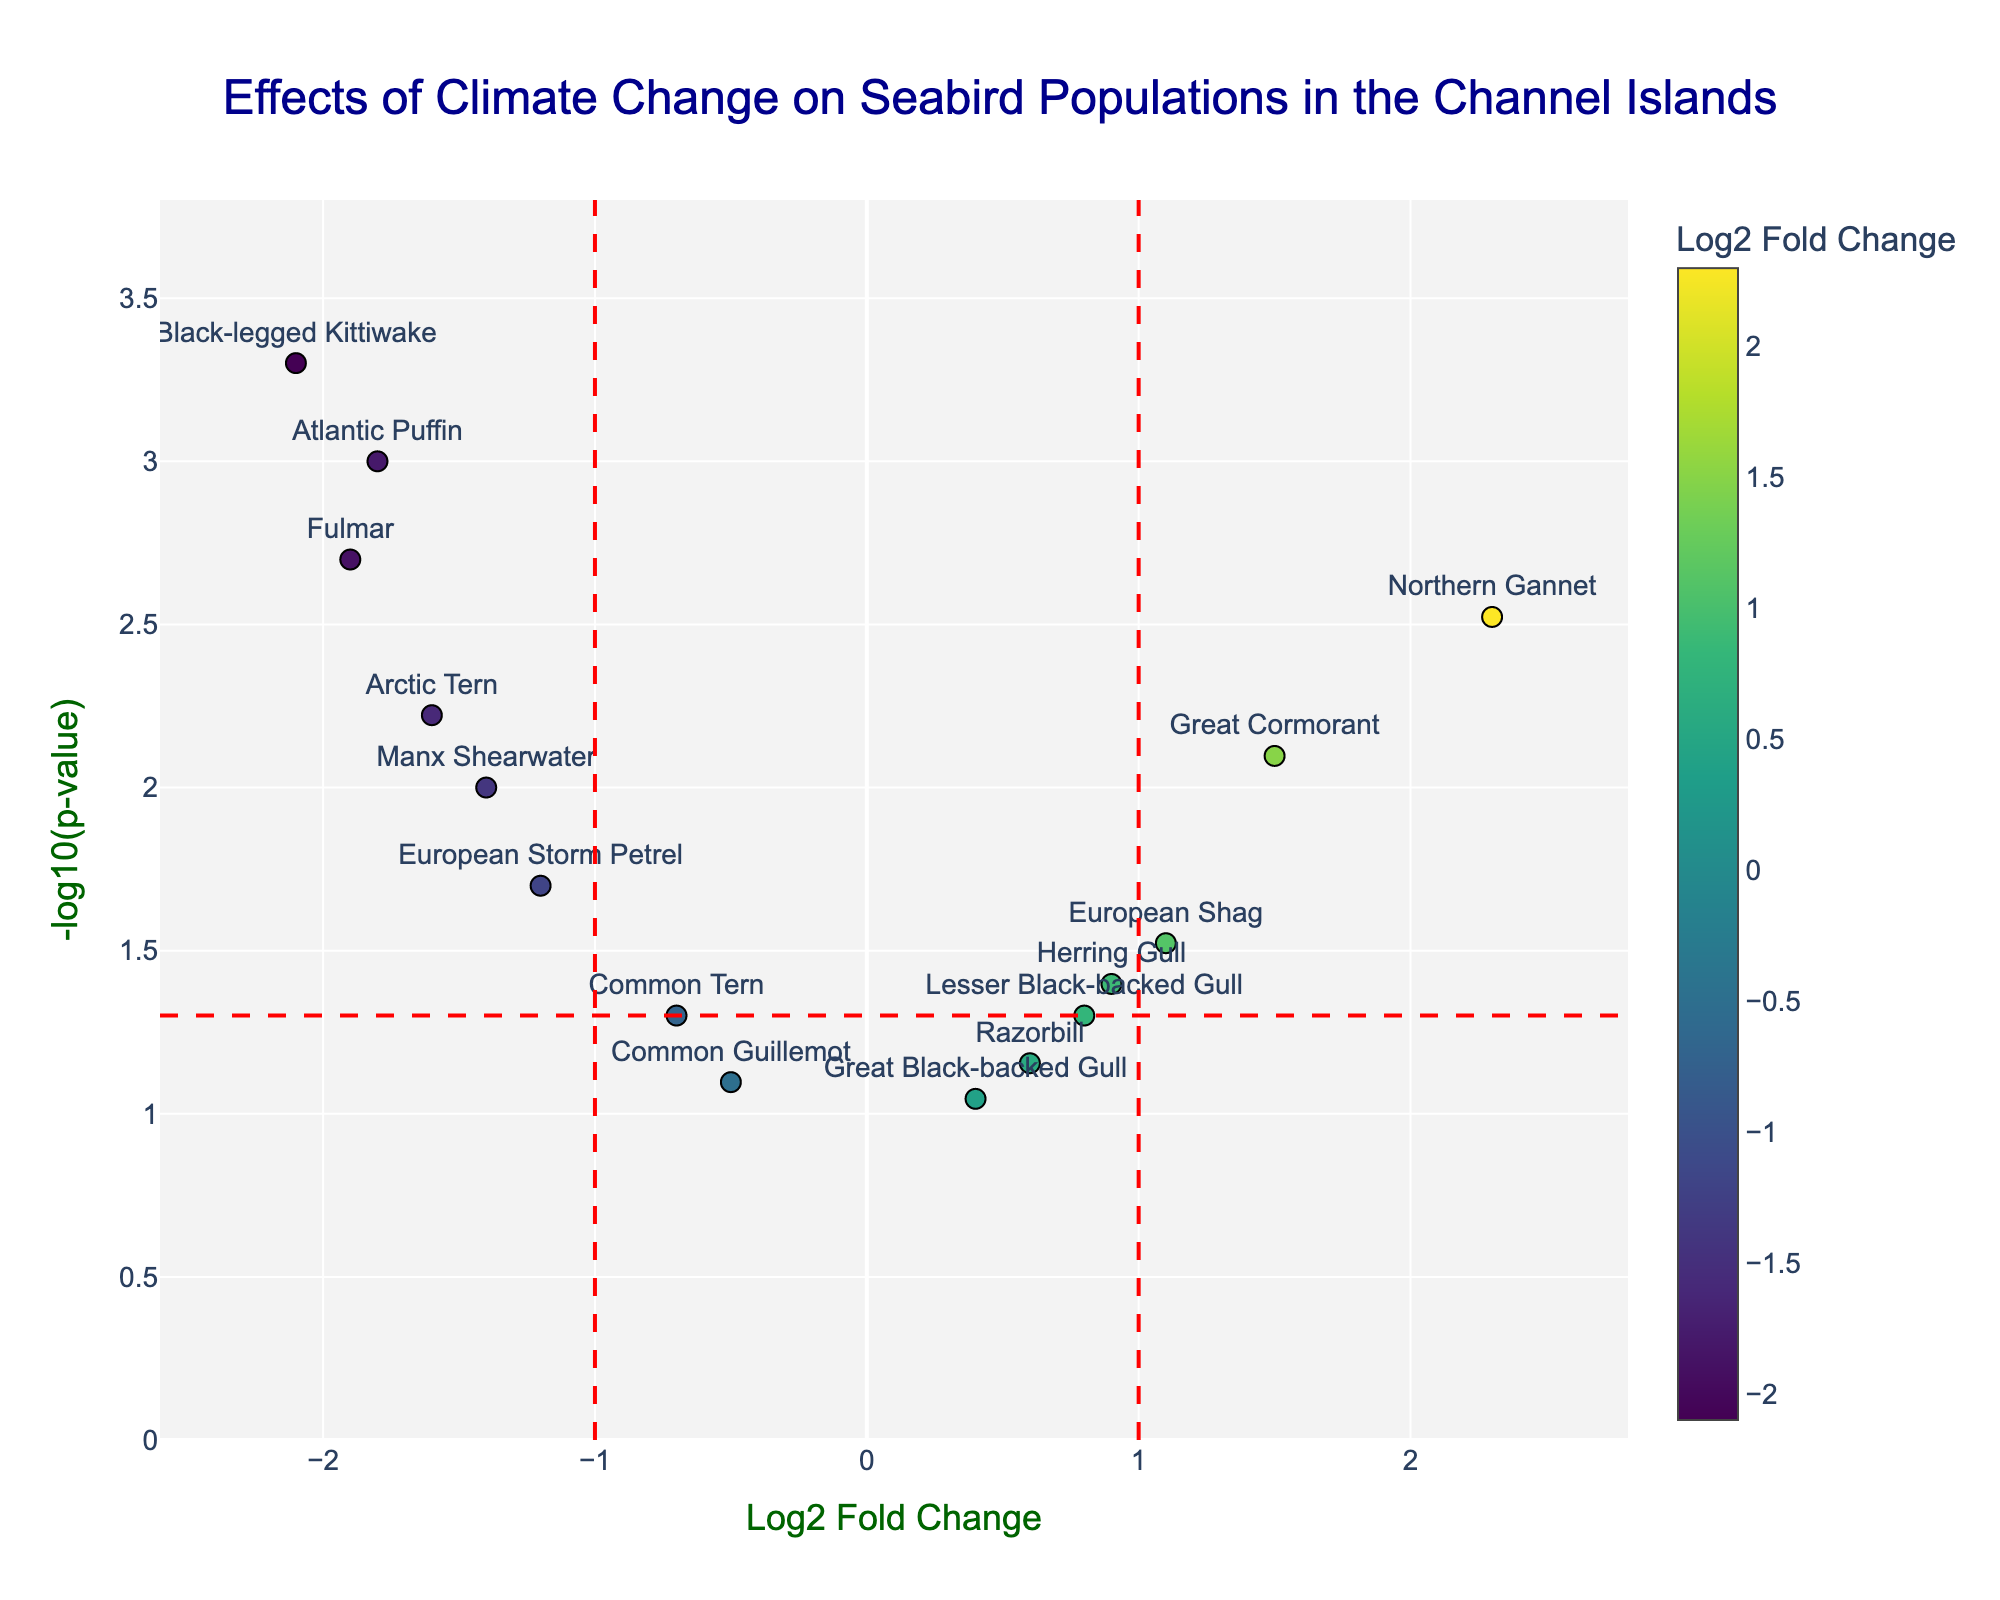What is the title of the figure? The title of the figure is displayed at the top center of the plot.
Answer: Effects of Climate Change on Seabird Populations in the Channel Islands Which species shows the largest negative Log2 Fold Change? To determine the species with the largest negative Log2 Fold Change, look for the data point with the lowest Log2 Fold Change value on the x-axis.
Answer: Black-legged Kittiwake How many species have a p-value less than 0.05? Identify the points above the dashed red horizontal line, which represents the p-value threshold of 0.05. Count the number of these points.
Answer: 10 What is the Log2 Fold Change for Northern Gannet? Locate the data point labeled "Northern Gannet" and read its x-axis value (Log2 Fold Change).
Answer: 2.3 Which species have both a p-value less than 0.05 and a Log2 Fold Change greater than 1? Look at the points above the dashed red horizontal line and to the right of the dashed red vertical line at Log2 Fold Change = 1. Identify the species corresponding to these points.
Answer: Northern Gannet, Great Cormorant, European Shag What color scale is used to represent the Log2 Fold Change values? The color of the data points varies according to the Log2 Fold Change values and uses a specific color scale. Identify the color scale from the plot legend.
Answer: Viridis How many species have a negative Log2 Fold Change that is statistically significant (p-value < 0.05)? Count the points left of the dashed red vertical line at Log2 Fold Change = -1 and above the horizontal dashed red line, indicating p-value < 0.05.
Answer: 6 Which species has the smallest p-value? Identify the species with the highest value on the y-axis, representing the smallest p-value.
Answer: Black-legged Kittiwake Are there more species with a positive Log2 Fold Change greater than 1 or with a negative Log2 Fold Change less than -1? Count the points to the right of Log2 Fold Change = 1 and compare the count with those to the left of Log2 Fold Change = -1.
Answer: Fewer species with a positive Log2 Fold Change What is the range of the y-axis (-log10(p-value)) in the plot? Determine the minimum and maximum values shown on the y-axis from the plot's axis labels and tick marks.
Answer: 0 to approximately 3.5 